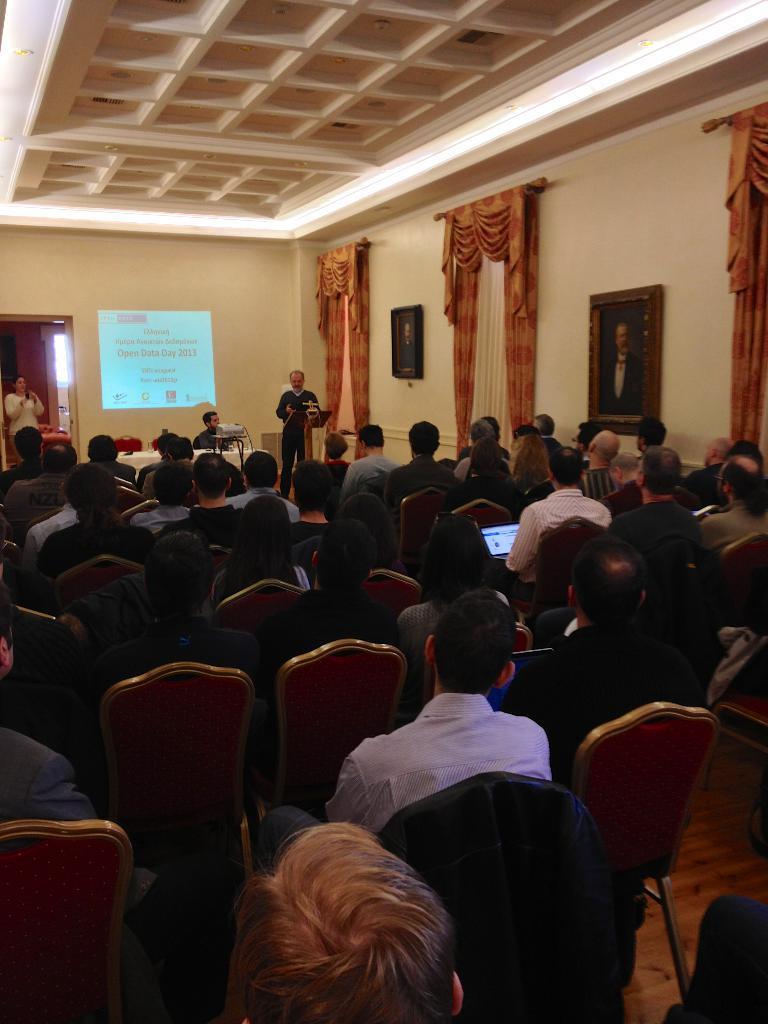In one or two sentences, can you explain what this image depicts? This is the picture where we have some people sitting on the chairs in front of them there is a man sitting on the chair in front of the table on which there are some things placed and a man standing in front of the desk and there is a screen, curtains and frames to the wall. 